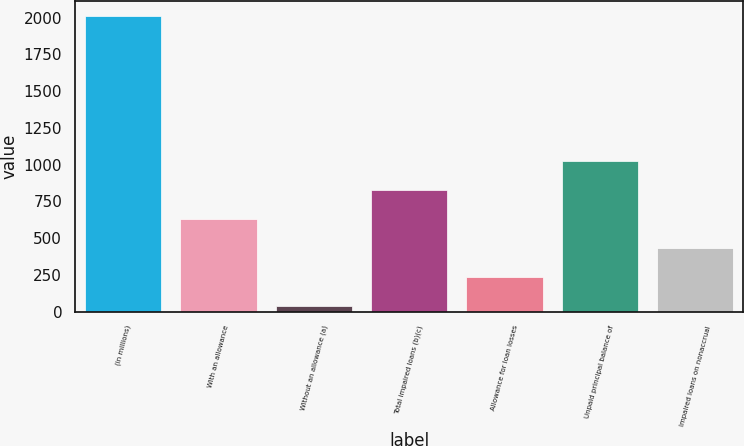Convert chart. <chart><loc_0><loc_0><loc_500><loc_500><bar_chart><fcel>(in millions)<fcel>With an allowance<fcel>Without an allowance (a)<fcel>Total impaired loans (b)(c)<fcel>Allowance for loan losses<fcel>Unpaid principal balance of<fcel>Impaired loans on nonaccrual<nl><fcel>2011<fcel>627.8<fcel>35<fcel>825.4<fcel>232.6<fcel>1023<fcel>430.2<nl></chart> 